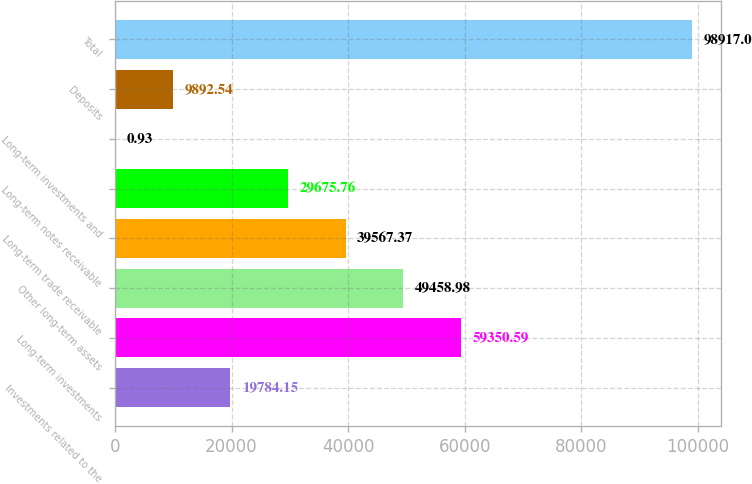Convert chart to OTSL. <chart><loc_0><loc_0><loc_500><loc_500><bar_chart><fcel>Investments related to the<fcel>Long-term investments<fcel>Other long-term assets<fcel>Long-term trade receivable<fcel>Long-term notes receivable<fcel>Long-term investments and<fcel>Deposits<fcel>Total<nl><fcel>19784.2<fcel>59350.6<fcel>49459<fcel>39567.4<fcel>29675.8<fcel>0.93<fcel>9892.54<fcel>98917<nl></chart> 